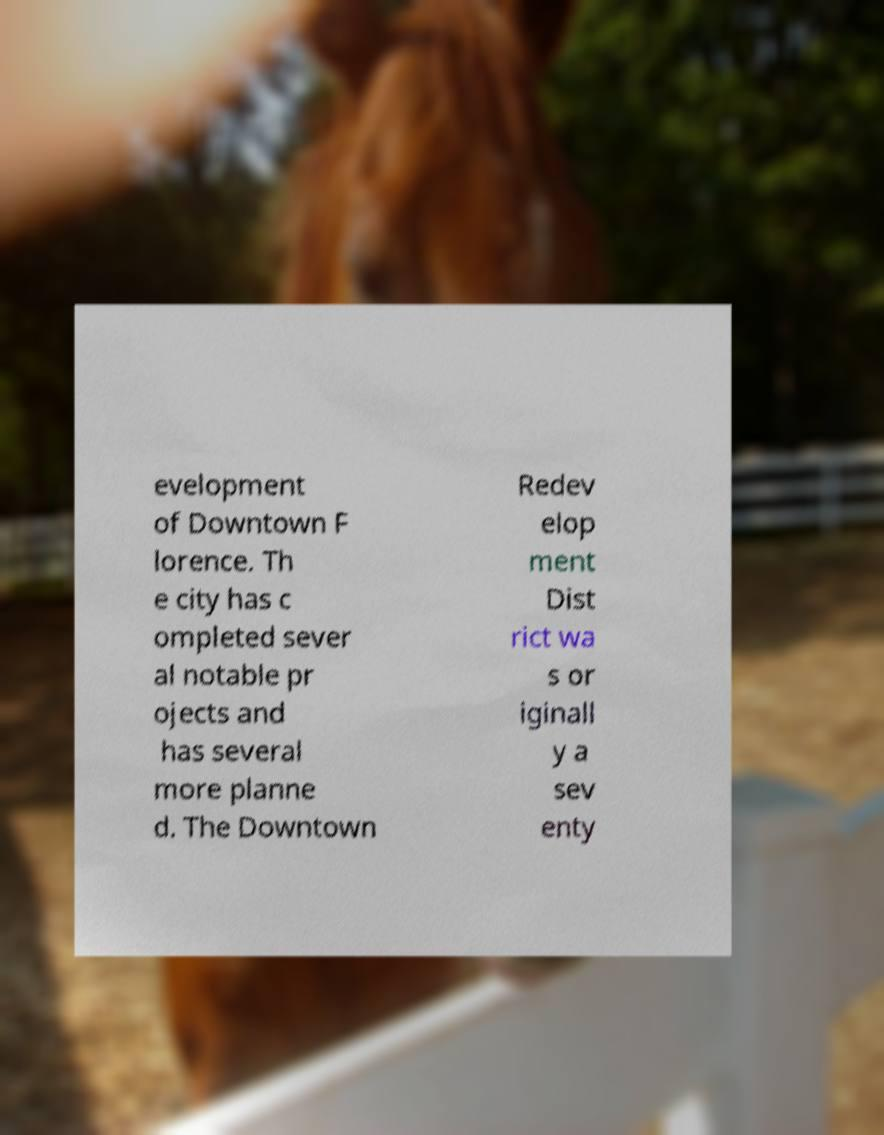I need the written content from this picture converted into text. Can you do that? evelopment of Downtown F lorence. Th e city has c ompleted sever al notable pr ojects and has several more planne d. The Downtown Redev elop ment Dist rict wa s or iginall y a sev enty 